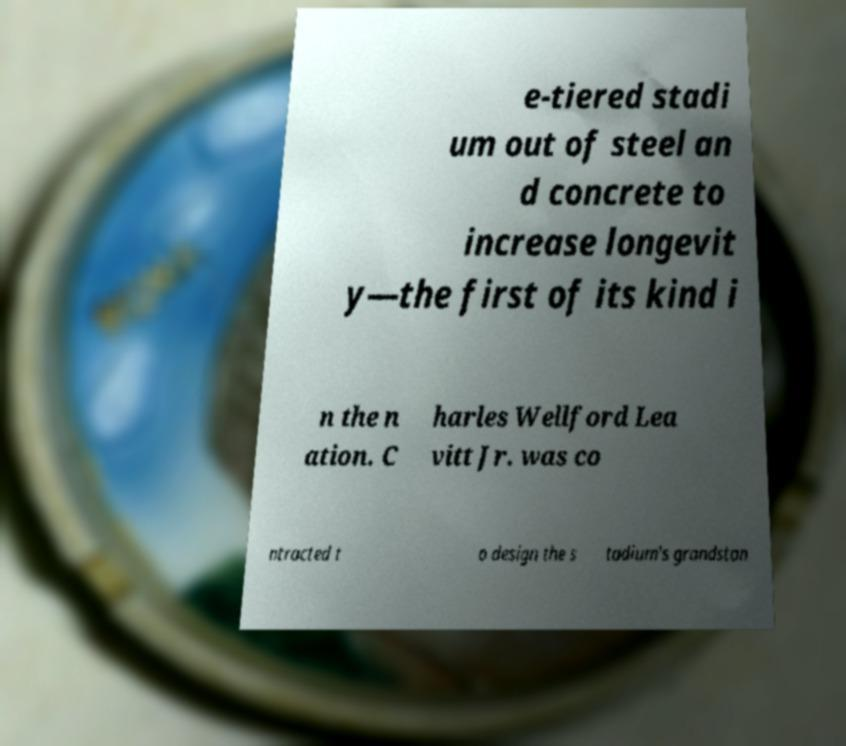Please read and relay the text visible in this image. What does it say? e-tiered stadi um out of steel an d concrete to increase longevit y—the first of its kind i n the n ation. C harles Wellford Lea vitt Jr. was co ntracted t o design the s tadium's grandstan 